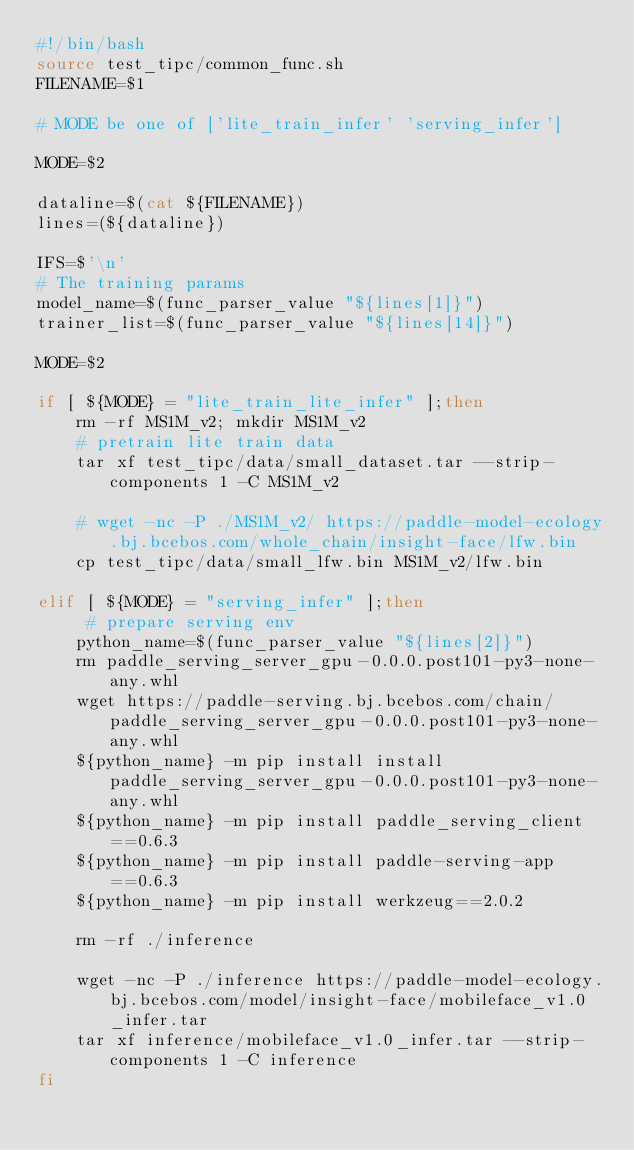<code> <loc_0><loc_0><loc_500><loc_500><_Bash_>#!/bin/bash
source test_tipc/common_func.sh
FILENAME=$1

# MODE be one of ['lite_train_infer' 'serving_infer']

MODE=$2

dataline=$(cat ${FILENAME})
lines=(${dataline})

IFS=$'\n'
# The training params
model_name=$(func_parser_value "${lines[1]}")
trainer_list=$(func_parser_value "${lines[14]}")

MODE=$2

if [ ${MODE} = "lite_train_lite_infer" ];then
    rm -rf MS1M_v2; mkdir MS1M_v2
    # pretrain lite train data
    tar xf test_tipc/data/small_dataset.tar --strip-components 1 -C MS1M_v2 
    
    # wget -nc -P ./MS1M_v2/ https://paddle-model-ecology.bj.bcebos.com/whole_chain/insight-face/lfw.bin
    cp test_tipc/data/small_lfw.bin MS1M_v2/lfw.bin

elif [ ${MODE} = "serving_infer" ];then
     # prepare serving env
    python_name=$(func_parser_value "${lines[2]}")
    rm paddle_serving_server_gpu-0.0.0.post101-py3-none-any.whl
    wget https://paddle-serving.bj.bcebos.com/chain/paddle_serving_server_gpu-0.0.0.post101-py3-none-any.whl
    ${python_name} -m pip install install paddle_serving_server_gpu-0.0.0.post101-py3-none-any.whl
    ${python_name} -m pip install paddle_serving_client==0.6.3
    ${python_name} -m pip install paddle-serving-app==0.6.3
    ${python_name} -m pip install werkzeug==2.0.2

    rm -rf ./inference

    wget -nc -P ./inference https://paddle-model-ecology.bj.bcebos.com/model/insight-face/mobileface_v1.0_infer.tar
    tar xf inference/mobileface_v1.0_infer.tar --strip-components 1 -C inference 
fi

</code> 